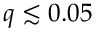Convert formula to latex. <formula><loc_0><loc_0><loc_500><loc_500>q \lesssim 0 . 0 5</formula> 